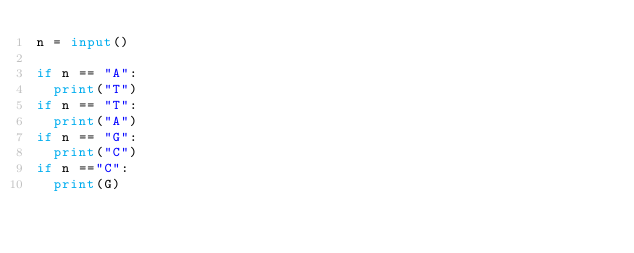Convert code to text. <code><loc_0><loc_0><loc_500><loc_500><_Python_>n = input()

if n == "A":
  print("T")
if n == "T":
  print("A")
if n == "G":
  print("C")
if n =="C":
  print(G)</code> 